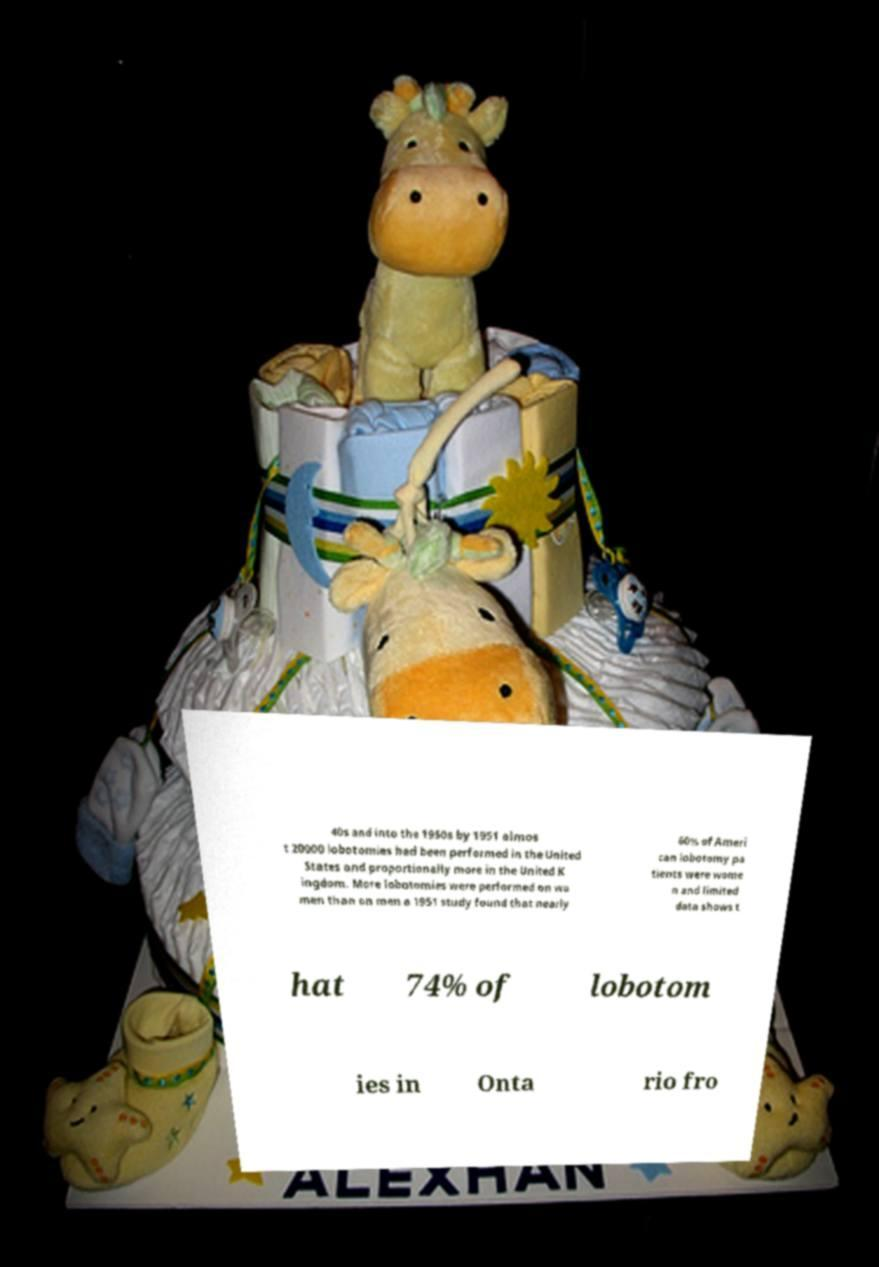Could you extract and type out the text from this image? 40s and into the 1950s by 1951 almos t 20000 lobotomies had been performed in the United States and proportionally more in the United K ingdom. More lobotomies were performed on wo men than on men a 1951 study found that nearly 60% of Ameri can lobotomy pa tients were wome n and limited data shows t hat 74% of lobotom ies in Onta rio fro 